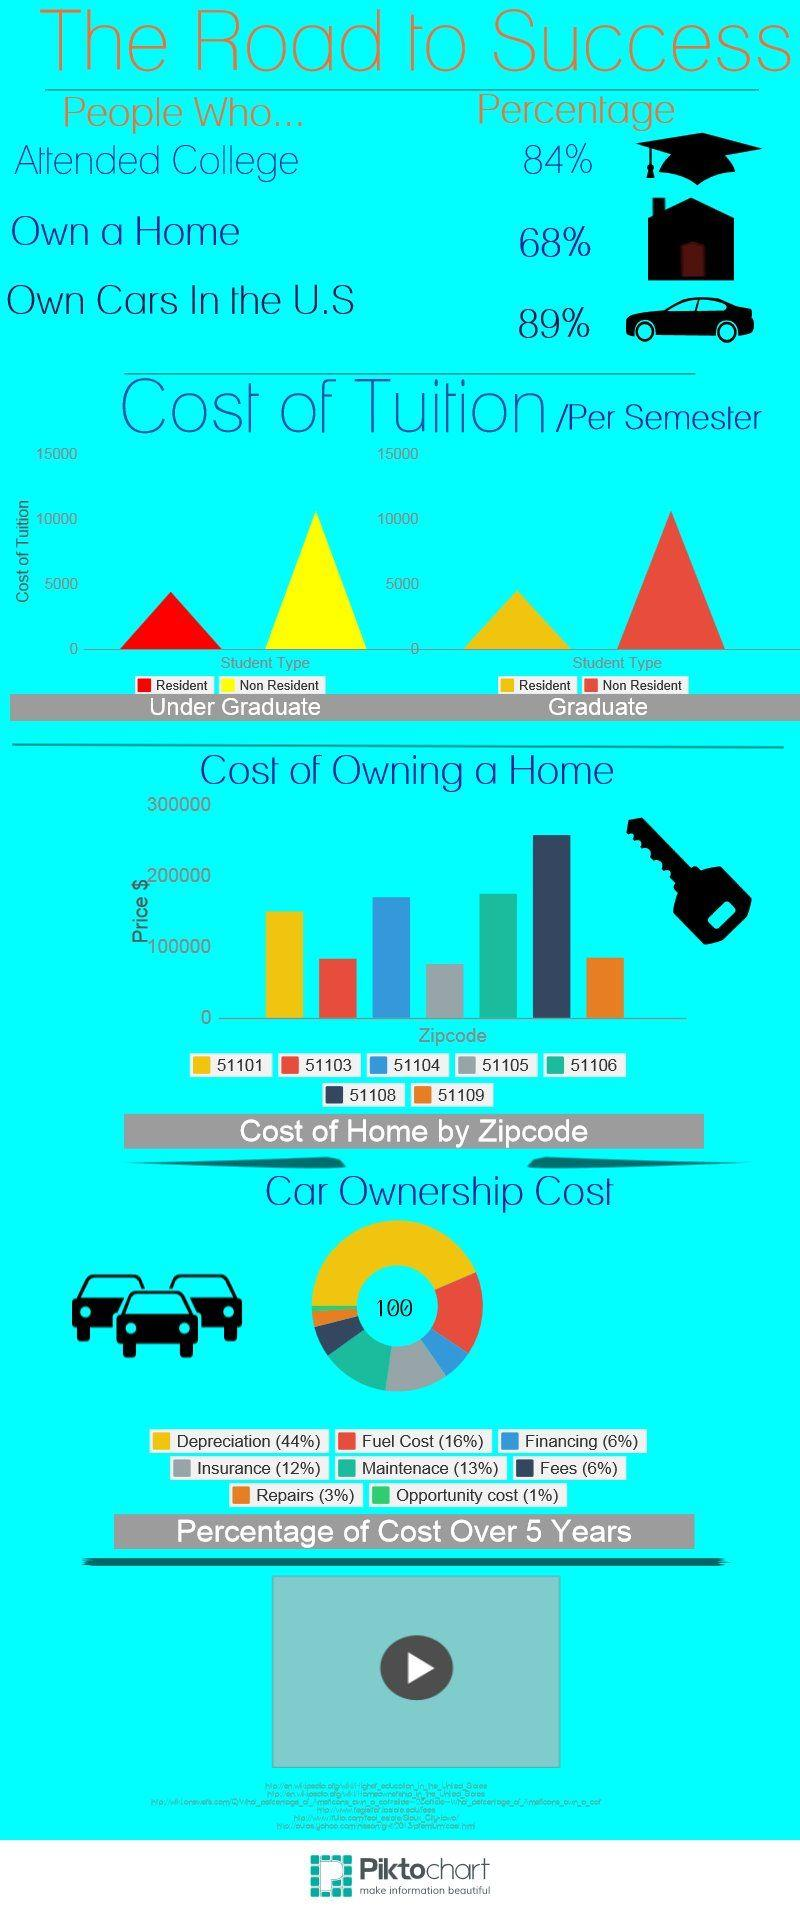Specify some key components in this picture. In the zip code area of 51108 in the United States, the cost of owning a home is above $200,000. Approximately 32% of people in the United States do not own a home. The cost of tuition per semester for non-resident students pursuing an undergraduate degree in the United States is approximately $10,000. In the United States, approximately 16% of people did not attend colleges. In certain zip code areas in the United States, the cost of owning a home is below $100,000, such as 51103, 51105, and 51109. 